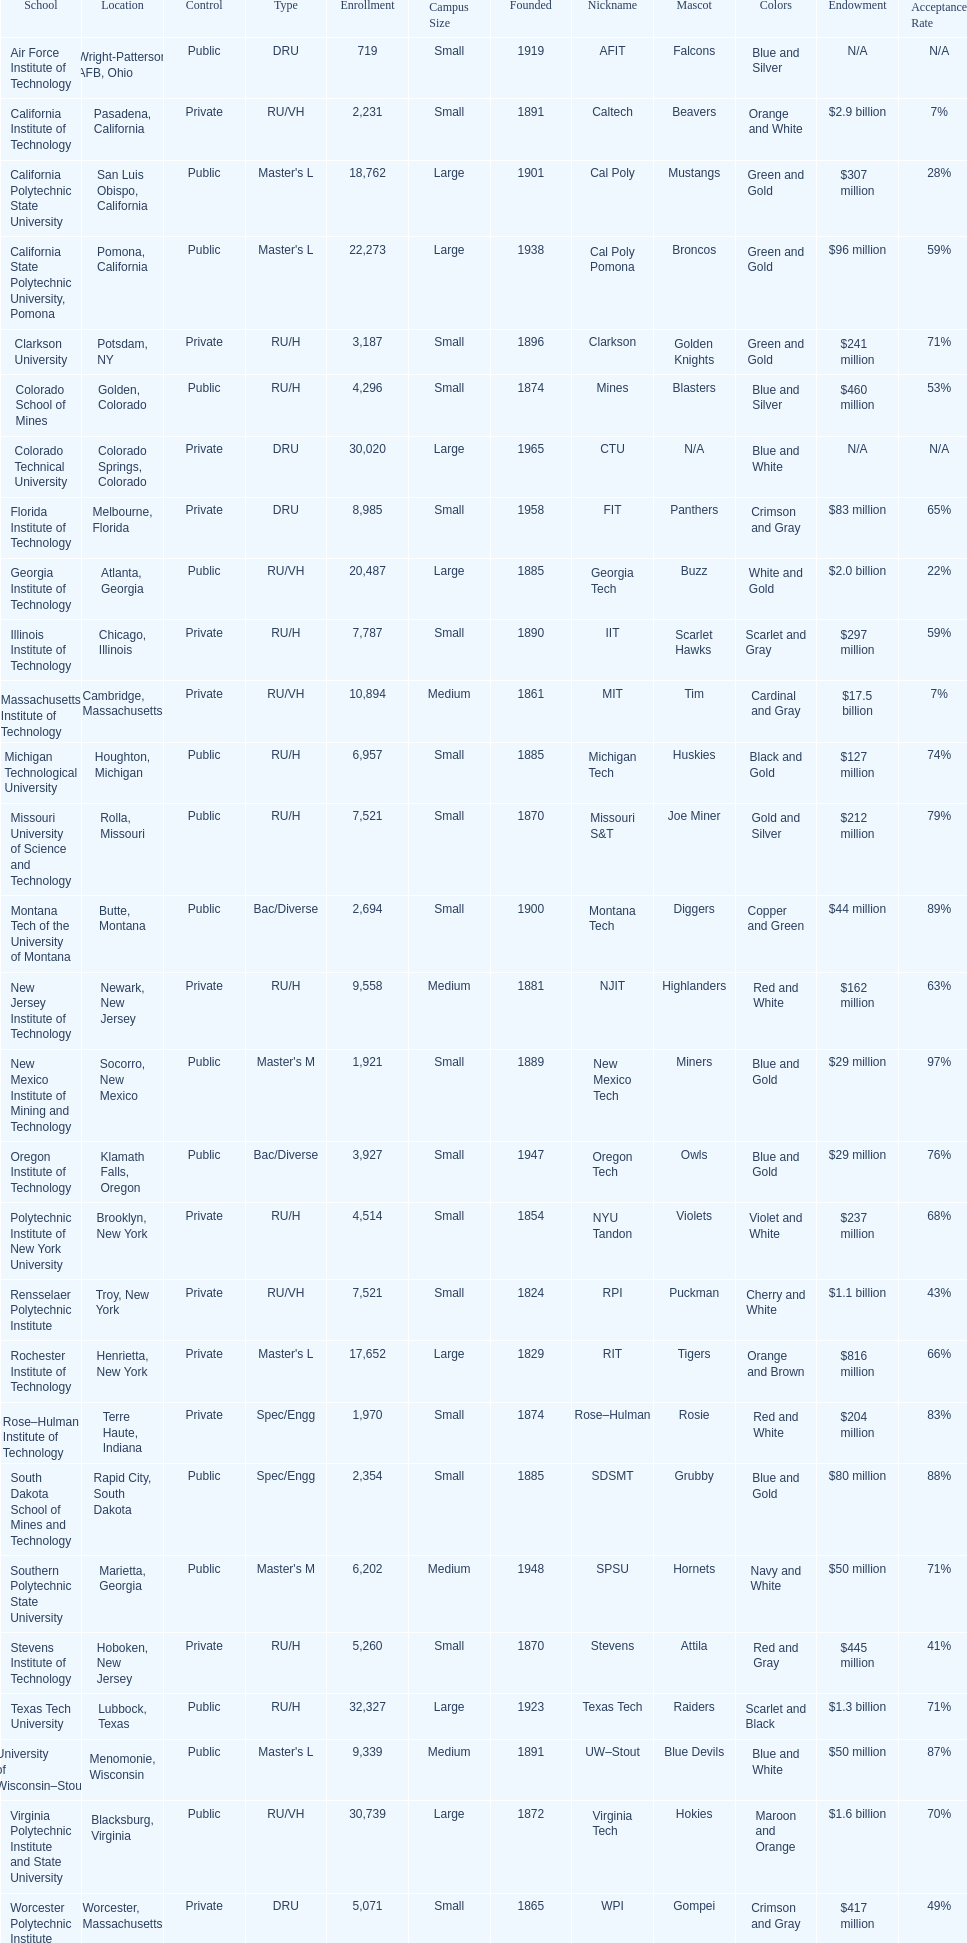What school is listed next after michigan technological university? Missouri University of Science and Technology. 